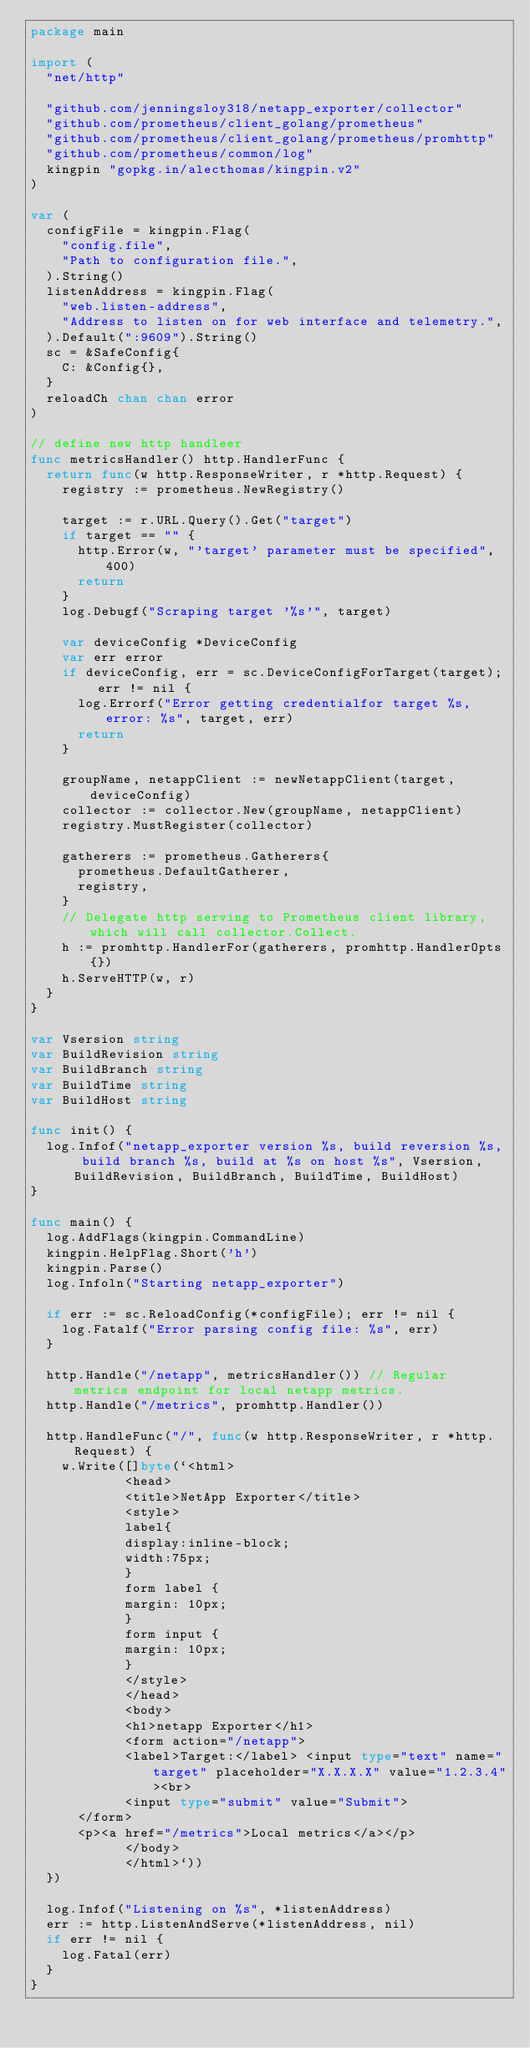<code> <loc_0><loc_0><loc_500><loc_500><_Go_>package main

import (
	"net/http"

	"github.com/jenningsloy318/netapp_exporter/collector"
	"github.com/prometheus/client_golang/prometheus"
	"github.com/prometheus/client_golang/prometheus/promhttp"
	"github.com/prometheus/common/log"
	kingpin "gopkg.in/alecthomas/kingpin.v2"
)

var (
	configFile = kingpin.Flag(
		"config.file",
		"Path to configuration file.",
	).String()
	listenAddress = kingpin.Flag(
		"web.listen-address",
		"Address to listen on for web interface and telemetry.",
	).Default(":9609").String()
	sc = &SafeConfig{
		C: &Config{},
	}
	reloadCh chan chan error
)

// define new http handleer
func metricsHandler() http.HandlerFunc {
	return func(w http.ResponseWriter, r *http.Request) {
		registry := prometheus.NewRegistry()

		target := r.URL.Query().Get("target")
		if target == "" {
			http.Error(w, "'target' parameter must be specified", 400)
			return
		}
		log.Debugf("Scraping target '%s'", target)

		var deviceConfig *DeviceConfig
		var err error
		if deviceConfig, err = sc.DeviceConfigForTarget(target); err != nil {
			log.Errorf("Error getting credentialfor target %s, error: %s", target, err)
			return
		}

		groupName, netappClient := newNetappClient(target, deviceConfig)
		collector := collector.New(groupName, netappClient)
		registry.MustRegister(collector)

		gatherers := prometheus.Gatherers{
			prometheus.DefaultGatherer,
			registry,
		}
		// Delegate http serving to Prometheus client library, which will call collector.Collect.
		h := promhttp.HandlerFor(gatherers, promhttp.HandlerOpts{})
		h.ServeHTTP(w, r)
	}
}

var Vsersion string
var BuildRevision string
var BuildBranch string
var BuildTime string
var BuildHost string

func init() {
	log.Infof("netapp_exporter version %s, build reversion %s, build branch %s, build at %s on host %s", Vsersion, BuildRevision, BuildBranch, BuildTime, BuildHost)
}

func main() {
	log.AddFlags(kingpin.CommandLine)
	kingpin.HelpFlag.Short('h')
	kingpin.Parse()
	log.Infoln("Starting netapp_exporter")

	if err := sc.ReloadConfig(*configFile); err != nil {
		log.Fatalf("Error parsing config file: %s", err)
	}

	http.Handle("/netapp", metricsHandler()) // Regular metrics endpoint for local netapp metrics.
	http.Handle("/metrics", promhttp.Handler())

	http.HandleFunc("/", func(w http.ResponseWriter, r *http.Request) {
		w.Write([]byte(`<html>
            <head>
            <title>NetApp Exporter</title>
            <style>
            label{
            display:inline-block;
            width:75px;
            }
            form label {
            margin: 10px;
            }
            form input {
            margin: 10px;
            }
            </style>
            </head>
            <body>
            <h1>netapp Exporter</h1>
            <form action="/netapp">
            <label>Target:</label> <input type="text" name="target" placeholder="X.X.X.X" value="1.2.3.4"><br>
            <input type="submit" value="Submit">
			</form>
			<p><a href="/metrics">Local metrics</a></p>
            </body>
            </html>`))
	})

	log.Infof("Listening on %s", *listenAddress)
	err := http.ListenAndServe(*listenAddress, nil)
	if err != nil {
		log.Fatal(err)
	}
}
</code> 